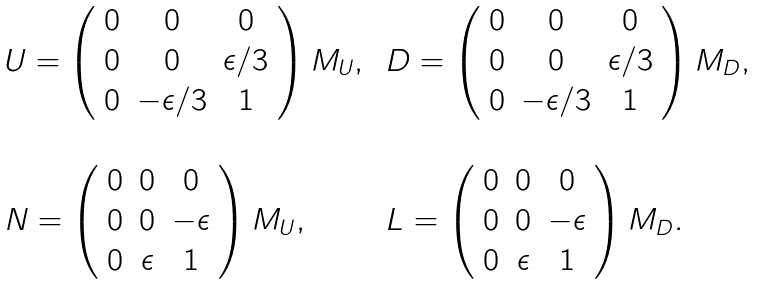<formula> <loc_0><loc_0><loc_500><loc_500>\begin{array} { l l } U = \left ( \begin{array} { c c c } 0 & 0 & 0 \\ 0 & 0 & \epsilon / 3 \\ 0 & - \epsilon / 3 & 1 \end{array} \right ) M _ { U } , \, & D = \left ( \begin{array} { c c c } 0 & 0 & 0 \\ 0 & 0 & \epsilon / 3 \\ 0 & - \epsilon / 3 & 1 \end{array} \right ) M _ { D } , \\ & \\ N = \left ( \begin{array} { c c c } 0 & 0 & 0 \\ 0 & 0 & - \epsilon \\ 0 & \epsilon & 1 \end{array} \right ) M _ { U } , \, & L = \left ( \begin{array} { c c c } 0 & 0 & 0 \\ 0 & 0 & - \epsilon \\ 0 & \epsilon & 1 \end{array} \right ) M _ { D } . \\ & \end{array}</formula> 